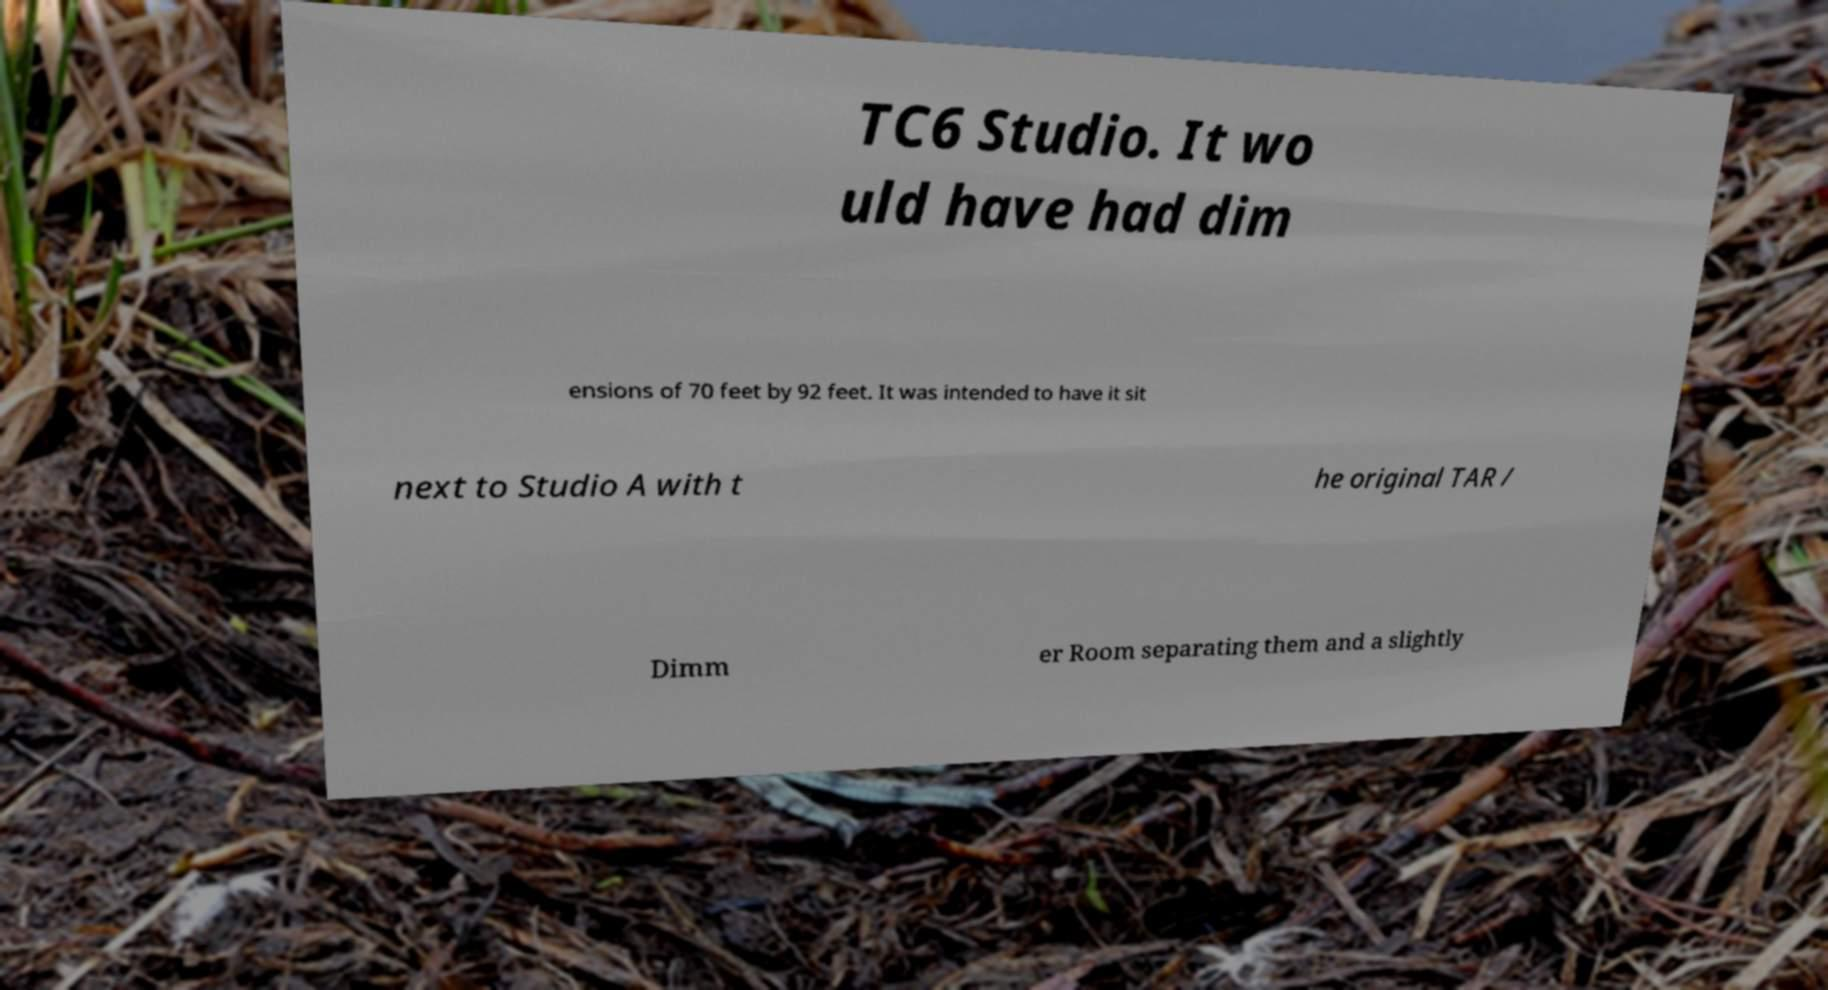Could you extract and type out the text from this image? TC6 Studio. It wo uld have had dim ensions of 70 feet by 92 feet. It was intended to have it sit next to Studio A with t he original TAR / Dimm er Room separating them and a slightly 